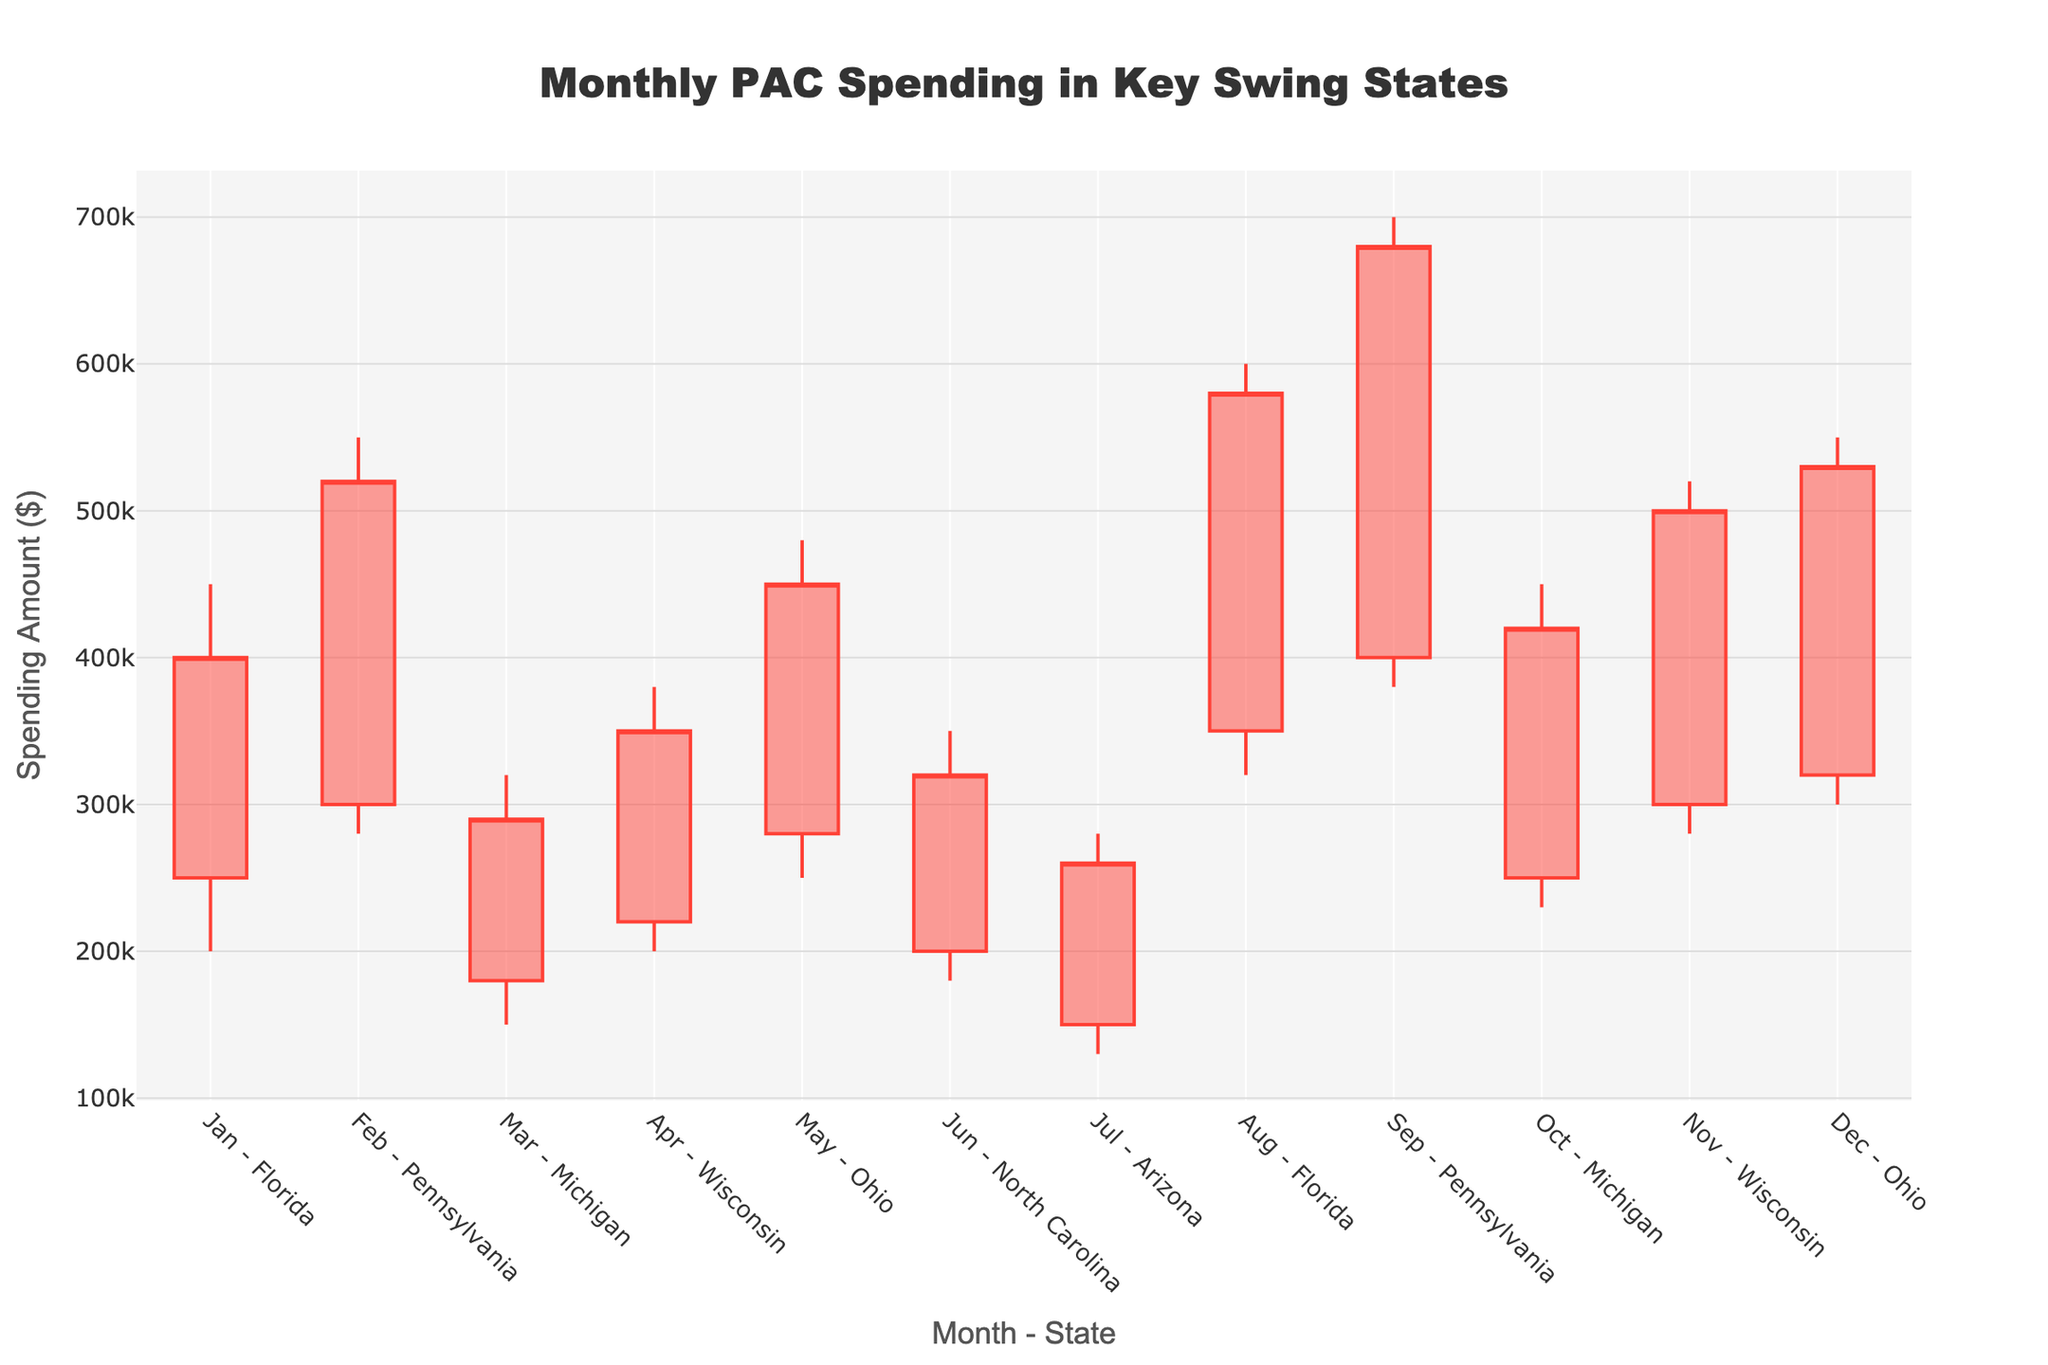Which state had the highest single-month PAC spending? By analyzing the high values of each candlestick, we see that Pennsylvania had the highest single-month PAC spending, with a high value of $700,000 in September.
Answer: Pennsylvania What was the closing amount for Florida in January? Locate the candlestick for "Jan - Florida" and refer to the close value, which is $400,000.
Answer: $400,000 Which months had the highest PAC spending in Florida? Florida appears twice (January and August). By comparing their high values (January: $450,000, August: $600,000), August has the highest spending.
Answer: August What is the average closing amount for all states listed? Sum all closing values ($400,000 + $520,000 + $290,000 + $350,000 + $450,000 + $320,000 + $260,000 + $580,000 + $680,000 + $420,000 + $500,000 + $530,000) = $5,300,000. There are 12 data points, so the average is $5,300,000 / 12 = $441,666.67.
Answer: $441,666.67 Which state had the smallest range of PAC spending (High-Low) in any month? Calculate the difference between high and low for each state: Florida (January: $250,000), Pennsylvania (February: $270,000), Michigan (March: $170,000), Wisconsin (April: $180,000), Ohio (May: $230,000), North Carolina (June: $170,000), Arizona (July: $150,000), Florida (August: $280,000), Pennsylvania (September: $320,000), Michigan (October: $220,000), Wisconsin (November: $240,000), Ohio (December: $250,000). The smallest range is Arizona in July with $150,000.
Answer: Arizona What is the total PAC spending for Pennsylvania across all months? The total spending for Pennsylvania is the sum of its close values ($520,000 + $680,000) = $1,200,000.
Answer: $1,200,000 Which month had the most significant increase in PAC spending for Michigan? For Michigan, compare open and close values in March (Open: $180,000, Close: $290,000, increase: $110,000) and October (Open: $250,000, Close: $420,000, increase: $170,000). October shows the most significant increase.
Answer: October Was there any month where the closing PAC spending was equal to the opening spending? Inspect each candlestick for open and close equality. None of the candlesticks show equal open and close values.
Answer: No What is the difference in the closing amount between the highest-spending and the lowest-spending states? The highest closing amount is $680,000 (Pennsylvania in September), and the lowest is $260,000 (Arizona in July). The difference is $680,000 - $260,000 = $420,000.
Answer: $420,000 In which month did Ohio have the highest closing value? Ohio appears in May and December. Comparing close values ($450,000 in May and $530,000 in December), December has the highest closing value.
Answer: December 